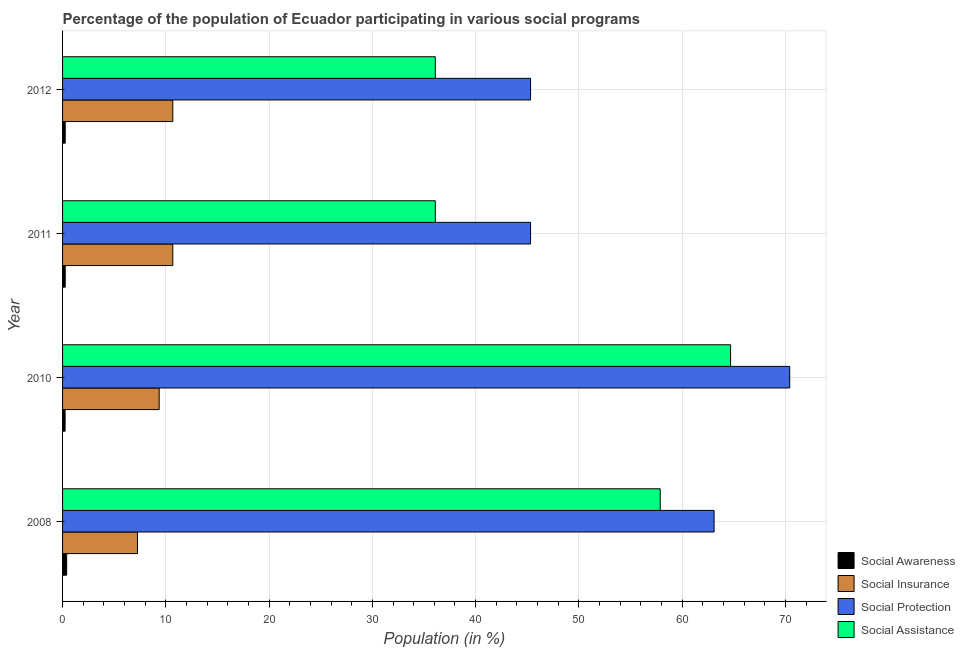How many different coloured bars are there?
Your answer should be very brief. 4. Are the number of bars on each tick of the Y-axis equal?
Provide a short and direct response. Yes. How many bars are there on the 1st tick from the top?
Your answer should be compact. 4. In how many cases, is the number of bars for a given year not equal to the number of legend labels?
Ensure brevity in your answer.  0. What is the participation of population in social protection programs in 2010?
Ensure brevity in your answer.  70.42. Across all years, what is the maximum participation of population in social assistance programs?
Provide a short and direct response. 64.69. Across all years, what is the minimum participation of population in social awareness programs?
Give a very brief answer. 0.25. What is the total participation of population in social protection programs in the graph?
Offer a terse response. 224.15. What is the difference between the participation of population in social awareness programs in 2008 and that in 2012?
Your answer should be very brief. 0.14. What is the difference between the participation of population in social awareness programs in 2008 and the participation of population in social protection programs in 2011?
Provide a succinct answer. -44.92. What is the average participation of population in social awareness programs per year?
Provide a short and direct response. 0.29. In the year 2012, what is the difference between the participation of population in social assistance programs and participation of population in social insurance programs?
Keep it short and to the point. 25.42. In how many years, is the participation of population in social assistance programs greater than 20 %?
Your answer should be compact. 4. What is the ratio of the participation of population in social awareness programs in 2011 to that in 2012?
Offer a very short reply. 1. Is the difference between the participation of population in social insurance programs in 2010 and 2011 greater than the difference between the participation of population in social assistance programs in 2010 and 2011?
Your answer should be compact. No. What is the difference between the highest and the second highest participation of population in social awareness programs?
Keep it short and to the point. 0.14. What is the difference between the highest and the lowest participation of population in social awareness programs?
Give a very brief answer. 0.15. In how many years, is the participation of population in social awareness programs greater than the average participation of population in social awareness programs taken over all years?
Make the answer very short. 1. What does the 2nd bar from the top in 2010 represents?
Give a very brief answer. Social Protection. What does the 3rd bar from the bottom in 2010 represents?
Make the answer very short. Social Protection. Is it the case that in every year, the sum of the participation of population in social awareness programs and participation of population in social insurance programs is greater than the participation of population in social protection programs?
Provide a succinct answer. No. How many bars are there?
Give a very brief answer. 16. How many years are there in the graph?
Provide a succinct answer. 4. What is the difference between two consecutive major ticks on the X-axis?
Your answer should be compact. 10. Does the graph contain any zero values?
Your answer should be compact. No. Does the graph contain grids?
Offer a very short reply. Yes. How are the legend labels stacked?
Your answer should be compact. Vertical. What is the title of the graph?
Keep it short and to the point. Percentage of the population of Ecuador participating in various social programs . What is the Population (in %) of Social Awareness in 2008?
Your response must be concise. 0.4. What is the Population (in %) of Social Insurance in 2008?
Provide a succinct answer. 7.26. What is the Population (in %) of Social Protection in 2008?
Keep it short and to the point. 63.09. What is the Population (in %) of Social Assistance in 2008?
Provide a succinct answer. 57.88. What is the Population (in %) of Social Awareness in 2010?
Make the answer very short. 0.25. What is the Population (in %) of Social Insurance in 2010?
Make the answer very short. 9.35. What is the Population (in %) in Social Protection in 2010?
Your response must be concise. 70.42. What is the Population (in %) in Social Assistance in 2010?
Provide a short and direct response. 64.69. What is the Population (in %) of Social Awareness in 2011?
Give a very brief answer. 0.26. What is the Population (in %) in Social Insurance in 2011?
Keep it short and to the point. 10.67. What is the Population (in %) in Social Protection in 2011?
Keep it short and to the point. 45.32. What is the Population (in %) of Social Assistance in 2011?
Ensure brevity in your answer.  36.1. What is the Population (in %) in Social Awareness in 2012?
Ensure brevity in your answer.  0.26. What is the Population (in %) in Social Insurance in 2012?
Ensure brevity in your answer.  10.67. What is the Population (in %) in Social Protection in 2012?
Your answer should be very brief. 45.32. What is the Population (in %) in Social Assistance in 2012?
Ensure brevity in your answer.  36.1. Across all years, what is the maximum Population (in %) in Social Awareness?
Your answer should be compact. 0.4. Across all years, what is the maximum Population (in %) in Social Insurance?
Offer a very short reply. 10.67. Across all years, what is the maximum Population (in %) in Social Protection?
Keep it short and to the point. 70.42. Across all years, what is the maximum Population (in %) of Social Assistance?
Offer a very short reply. 64.69. Across all years, what is the minimum Population (in %) in Social Awareness?
Give a very brief answer. 0.25. Across all years, what is the minimum Population (in %) in Social Insurance?
Offer a terse response. 7.26. Across all years, what is the minimum Population (in %) in Social Protection?
Your answer should be very brief. 45.32. Across all years, what is the minimum Population (in %) in Social Assistance?
Offer a terse response. 36.1. What is the total Population (in %) in Social Awareness in the graph?
Ensure brevity in your answer.  1.16. What is the total Population (in %) of Social Insurance in the graph?
Keep it short and to the point. 37.96. What is the total Population (in %) in Social Protection in the graph?
Provide a succinct answer. 224.15. What is the total Population (in %) of Social Assistance in the graph?
Keep it short and to the point. 194.76. What is the difference between the Population (in %) in Social Awareness in 2008 and that in 2010?
Ensure brevity in your answer.  0.15. What is the difference between the Population (in %) of Social Insurance in 2008 and that in 2010?
Keep it short and to the point. -2.1. What is the difference between the Population (in %) of Social Protection in 2008 and that in 2010?
Your response must be concise. -7.32. What is the difference between the Population (in %) of Social Assistance in 2008 and that in 2010?
Make the answer very short. -6.81. What is the difference between the Population (in %) of Social Awareness in 2008 and that in 2011?
Offer a terse response. 0.14. What is the difference between the Population (in %) of Social Insurance in 2008 and that in 2011?
Offer a very short reply. -3.42. What is the difference between the Population (in %) in Social Protection in 2008 and that in 2011?
Provide a short and direct response. 17.77. What is the difference between the Population (in %) in Social Assistance in 2008 and that in 2011?
Make the answer very short. 21.78. What is the difference between the Population (in %) of Social Awareness in 2008 and that in 2012?
Your answer should be compact. 0.14. What is the difference between the Population (in %) of Social Insurance in 2008 and that in 2012?
Offer a very short reply. -3.42. What is the difference between the Population (in %) in Social Protection in 2008 and that in 2012?
Provide a short and direct response. 17.77. What is the difference between the Population (in %) of Social Assistance in 2008 and that in 2012?
Offer a very short reply. 21.78. What is the difference between the Population (in %) in Social Awareness in 2010 and that in 2011?
Give a very brief answer. -0.01. What is the difference between the Population (in %) in Social Insurance in 2010 and that in 2011?
Ensure brevity in your answer.  -1.32. What is the difference between the Population (in %) of Social Protection in 2010 and that in 2011?
Your answer should be very brief. 25.1. What is the difference between the Population (in %) of Social Assistance in 2010 and that in 2011?
Provide a short and direct response. 28.59. What is the difference between the Population (in %) of Social Awareness in 2010 and that in 2012?
Your response must be concise. -0.01. What is the difference between the Population (in %) in Social Insurance in 2010 and that in 2012?
Your answer should be compact. -1.32. What is the difference between the Population (in %) of Social Protection in 2010 and that in 2012?
Provide a short and direct response. 25.1. What is the difference between the Population (in %) in Social Assistance in 2010 and that in 2012?
Your answer should be compact. 28.59. What is the difference between the Population (in %) of Social Awareness in 2008 and the Population (in %) of Social Insurance in 2010?
Give a very brief answer. -8.96. What is the difference between the Population (in %) of Social Awareness in 2008 and the Population (in %) of Social Protection in 2010?
Provide a succinct answer. -70.02. What is the difference between the Population (in %) in Social Awareness in 2008 and the Population (in %) in Social Assistance in 2010?
Make the answer very short. -64.29. What is the difference between the Population (in %) in Social Insurance in 2008 and the Population (in %) in Social Protection in 2010?
Give a very brief answer. -63.16. What is the difference between the Population (in %) of Social Insurance in 2008 and the Population (in %) of Social Assistance in 2010?
Offer a terse response. -57.43. What is the difference between the Population (in %) of Social Protection in 2008 and the Population (in %) of Social Assistance in 2010?
Offer a terse response. -1.6. What is the difference between the Population (in %) in Social Awareness in 2008 and the Population (in %) in Social Insurance in 2011?
Provide a succinct answer. -10.28. What is the difference between the Population (in %) in Social Awareness in 2008 and the Population (in %) in Social Protection in 2011?
Keep it short and to the point. -44.92. What is the difference between the Population (in %) in Social Awareness in 2008 and the Population (in %) in Social Assistance in 2011?
Give a very brief answer. -35.7. What is the difference between the Population (in %) in Social Insurance in 2008 and the Population (in %) in Social Protection in 2011?
Provide a succinct answer. -38.07. What is the difference between the Population (in %) of Social Insurance in 2008 and the Population (in %) of Social Assistance in 2011?
Ensure brevity in your answer.  -28.84. What is the difference between the Population (in %) of Social Protection in 2008 and the Population (in %) of Social Assistance in 2011?
Provide a short and direct response. 26.99. What is the difference between the Population (in %) of Social Awareness in 2008 and the Population (in %) of Social Insurance in 2012?
Your answer should be compact. -10.28. What is the difference between the Population (in %) of Social Awareness in 2008 and the Population (in %) of Social Protection in 2012?
Provide a succinct answer. -44.92. What is the difference between the Population (in %) in Social Awareness in 2008 and the Population (in %) in Social Assistance in 2012?
Your answer should be compact. -35.7. What is the difference between the Population (in %) of Social Insurance in 2008 and the Population (in %) of Social Protection in 2012?
Your response must be concise. -38.07. What is the difference between the Population (in %) of Social Insurance in 2008 and the Population (in %) of Social Assistance in 2012?
Keep it short and to the point. -28.84. What is the difference between the Population (in %) in Social Protection in 2008 and the Population (in %) in Social Assistance in 2012?
Offer a terse response. 26.99. What is the difference between the Population (in %) in Social Awareness in 2010 and the Population (in %) in Social Insurance in 2011?
Your response must be concise. -10.43. What is the difference between the Population (in %) of Social Awareness in 2010 and the Population (in %) of Social Protection in 2011?
Your answer should be very brief. -45.07. What is the difference between the Population (in %) of Social Awareness in 2010 and the Population (in %) of Social Assistance in 2011?
Your answer should be compact. -35.85. What is the difference between the Population (in %) in Social Insurance in 2010 and the Population (in %) in Social Protection in 2011?
Your answer should be very brief. -35.97. What is the difference between the Population (in %) in Social Insurance in 2010 and the Population (in %) in Social Assistance in 2011?
Offer a terse response. -26.74. What is the difference between the Population (in %) in Social Protection in 2010 and the Population (in %) in Social Assistance in 2011?
Your answer should be very brief. 34.32. What is the difference between the Population (in %) of Social Awareness in 2010 and the Population (in %) of Social Insurance in 2012?
Your answer should be very brief. -10.43. What is the difference between the Population (in %) of Social Awareness in 2010 and the Population (in %) of Social Protection in 2012?
Your response must be concise. -45.07. What is the difference between the Population (in %) in Social Awareness in 2010 and the Population (in %) in Social Assistance in 2012?
Offer a very short reply. -35.85. What is the difference between the Population (in %) of Social Insurance in 2010 and the Population (in %) of Social Protection in 2012?
Your answer should be compact. -35.97. What is the difference between the Population (in %) of Social Insurance in 2010 and the Population (in %) of Social Assistance in 2012?
Your answer should be very brief. -26.74. What is the difference between the Population (in %) in Social Protection in 2010 and the Population (in %) in Social Assistance in 2012?
Give a very brief answer. 34.32. What is the difference between the Population (in %) of Social Awareness in 2011 and the Population (in %) of Social Insurance in 2012?
Your answer should be very brief. -10.42. What is the difference between the Population (in %) in Social Awareness in 2011 and the Population (in %) in Social Protection in 2012?
Make the answer very short. -45.06. What is the difference between the Population (in %) of Social Awareness in 2011 and the Population (in %) of Social Assistance in 2012?
Make the answer very short. -35.84. What is the difference between the Population (in %) of Social Insurance in 2011 and the Population (in %) of Social Protection in 2012?
Offer a terse response. -34.65. What is the difference between the Population (in %) of Social Insurance in 2011 and the Population (in %) of Social Assistance in 2012?
Make the answer very short. -25.42. What is the difference between the Population (in %) in Social Protection in 2011 and the Population (in %) in Social Assistance in 2012?
Your response must be concise. 9.22. What is the average Population (in %) in Social Awareness per year?
Provide a short and direct response. 0.29. What is the average Population (in %) of Social Insurance per year?
Your answer should be compact. 9.49. What is the average Population (in %) of Social Protection per year?
Offer a terse response. 56.04. What is the average Population (in %) in Social Assistance per year?
Ensure brevity in your answer.  48.69. In the year 2008, what is the difference between the Population (in %) of Social Awareness and Population (in %) of Social Insurance?
Your response must be concise. -6.86. In the year 2008, what is the difference between the Population (in %) in Social Awareness and Population (in %) in Social Protection?
Give a very brief answer. -62.7. In the year 2008, what is the difference between the Population (in %) in Social Awareness and Population (in %) in Social Assistance?
Your response must be concise. -57.48. In the year 2008, what is the difference between the Population (in %) of Social Insurance and Population (in %) of Social Protection?
Your answer should be very brief. -55.84. In the year 2008, what is the difference between the Population (in %) in Social Insurance and Population (in %) in Social Assistance?
Keep it short and to the point. -50.62. In the year 2008, what is the difference between the Population (in %) in Social Protection and Population (in %) in Social Assistance?
Your answer should be compact. 5.22. In the year 2010, what is the difference between the Population (in %) in Social Awareness and Population (in %) in Social Insurance?
Make the answer very short. -9.11. In the year 2010, what is the difference between the Population (in %) of Social Awareness and Population (in %) of Social Protection?
Keep it short and to the point. -70.17. In the year 2010, what is the difference between the Population (in %) of Social Awareness and Population (in %) of Social Assistance?
Provide a short and direct response. -64.44. In the year 2010, what is the difference between the Population (in %) of Social Insurance and Population (in %) of Social Protection?
Your response must be concise. -61.06. In the year 2010, what is the difference between the Population (in %) of Social Insurance and Population (in %) of Social Assistance?
Offer a terse response. -55.33. In the year 2010, what is the difference between the Population (in %) in Social Protection and Population (in %) in Social Assistance?
Give a very brief answer. 5.73. In the year 2011, what is the difference between the Population (in %) in Social Awareness and Population (in %) in Social Insurance?
Offer a very short reply. -10.42. In the year 2011, what is the difference between the Population (in %) of Social Awareness and Population (in %) of Social Protection?
Provide a short and direct response. -45.06. In the year 2011, what is the difference between the Population (in %) of Social Awareness and Population (in %) of Social Assistance?
Ensure brevity in your answer.  -35.84. In the year 2011, what is the difference between the Population (in %) in Social Insurance and Population (in %) in Social Protection?
Give a very brief answer. -34.65. In the year 2011, what is the difference between the Population (in %) of Social Insurance and Population (in %) of Social Assistance?
Your answer should be very brief. -25.42. In the year 2011, what is the difference between the Population (in %) of Social Protection and Population (in %) of Social Assistance?
Ensure brevity in your answer.  9.22. In the year 2012, what is the difference between the Population (in %) of Social Awareness and Population (in %) of Social Insurance?
Provide a succinct answer. -10.42. In the year 2012, what is the difference between the Population (in %) of Social Awareness and Population (in %) of Social Protection?
Offer a very short reply. -45.06. In the year 2012, what is the difference between the Population (in %) of Social Awareness and Population (in %) of Social Assistance?
Make the answer very short. -35.84. In the year 2012, what is the difference between the Population (in %) in Social Insurance and Population (in %) in Social Protection?
Your response must be concise. -34.65. In the year 2012, what is the difference between the Population (in %) of Social Insurance and Population (in %) of Social Assistance?
Offer a terse response. -25.42. In the year 2012, what is the difference between the Population (in %) of Social Protection and Population (in %) of Social Assistance?
Offer a very short reply. 9.22. What is the ratio of the Population (in %) of Social Awareness in 2008 to that in 2010?
Ensure brevity in your answer.  1.62. What is the ratio of the Population (in %) of Social Insurance in 2008 to that in 2010?
Your answer should be very brief. 0.78. What is the ratio of the Population (in %) of Social Protection in 2008 to that in 2010?
Offer a very short reply. 0.9. What is the ratio of the Population (in %) of Social Assistance in 2008 to that in 2010?
Make the answer very short. 0.89. What is the ratio of the Population (in %) in Social Awareness in 2008 to that in 2011?
Provide a short and direct response. 1.55. What is the ratio of the Population (in %) of Social Insurance in 2008 to that in 2011?
Offer a terse response. 0.68. What is the ratio of the Population (in %) in Social Protection in 2008 to that in 2011?
Give a very brief answer. 1.39. What is the ratio of the Population (in %) of Social Assistance in 2008 to that in 2011?
Your response must be concise. 1.6. What is the ratio of the Population (in %) of Social Awareness in 2008 to that in 2012?
Make the answer very short. 1.55. What is the ratio of the Population (in %) in Social Insurance in 2008 to that in 2012?
Your answer should be compact. 0.68. What is the ratio of the Population (in %) of Social Protection in 2008 to that in 2012?
Offer a terse response. 1.39. What is the ratio of the Population (in %) in Social Assistance in 2008 to that in 2012?
Make the answer very short. 1.6. What is the ratio of the Population (in %) of Social Awareness in 2010 to that in 2011?
Offer a terse response. 0.96. What is the ratio of the Population (in %) of Social Insurance in 2010 to that in 2011?
Provide a succinct answer. 0.88. What is the ratio of the Population (in %) of Social Protection in 2010 to that in 2011?
Make the answer very short. 1.55. What is the ratio of the Population (in %) of Social Assistance in 2010 to that in 2011?
Keep it short and to the point. 1.79. What is the ratio of the Population (in %) in Social Awareness in 2010 to that in 2012?
Offer a terse response. 0.96. What is the ratio of the Population (in %) of Social Insurance in 2010 to that in 2012?
Keep it short and to the point. 0.88. What is the ratio of the Population (in %) in Social Protection in 2010 to that in 2012?
Your answer should be compact. 1.55. What is the ratio of the Population (in %) of Social Assistance in 2010 to that in 2012?
Your response must be concise. 1.79. What is the ratio of the Population (in %) of Social Awareness in 2011 to that in 2012?
Make the answer very short. 1. What is the ratio of the Population (in %) in Social Insurance in 2011 to that in 2012?
Provide a succinct answer. 1. What is the ratio of the Population (in %) in Social Assistance in 2011 to that in 2012?
Your answer should be compact. 1. What is the difference between the highest and the second highest Population (in %) of Social Awareness?
Keep it short and to the point. 0.14. What is the difference between the highest and the second highest Population (in %) of Social Protection?
Your response must be concise. 7.32. What is the difference between the highest and the second highest Population (in %) of Social Assistance?
Offer a terse response. 6.81. What is the difference between the highest and the lowest Population (in %) in Social Awareness?
Your answer should be compact. 0.15. What is the difference between the highest and the lowest Population (in %) of Social Insurance?
Keep it short and to the point. 3.42. What is the difference between the highest and the lowest Population (in %) in Social Protection?
Your response must be concise. 25.1. What is the difference between the highest and the lowest Population (in %) of Social Assistance?
Your answer should be compact. 28.59. 